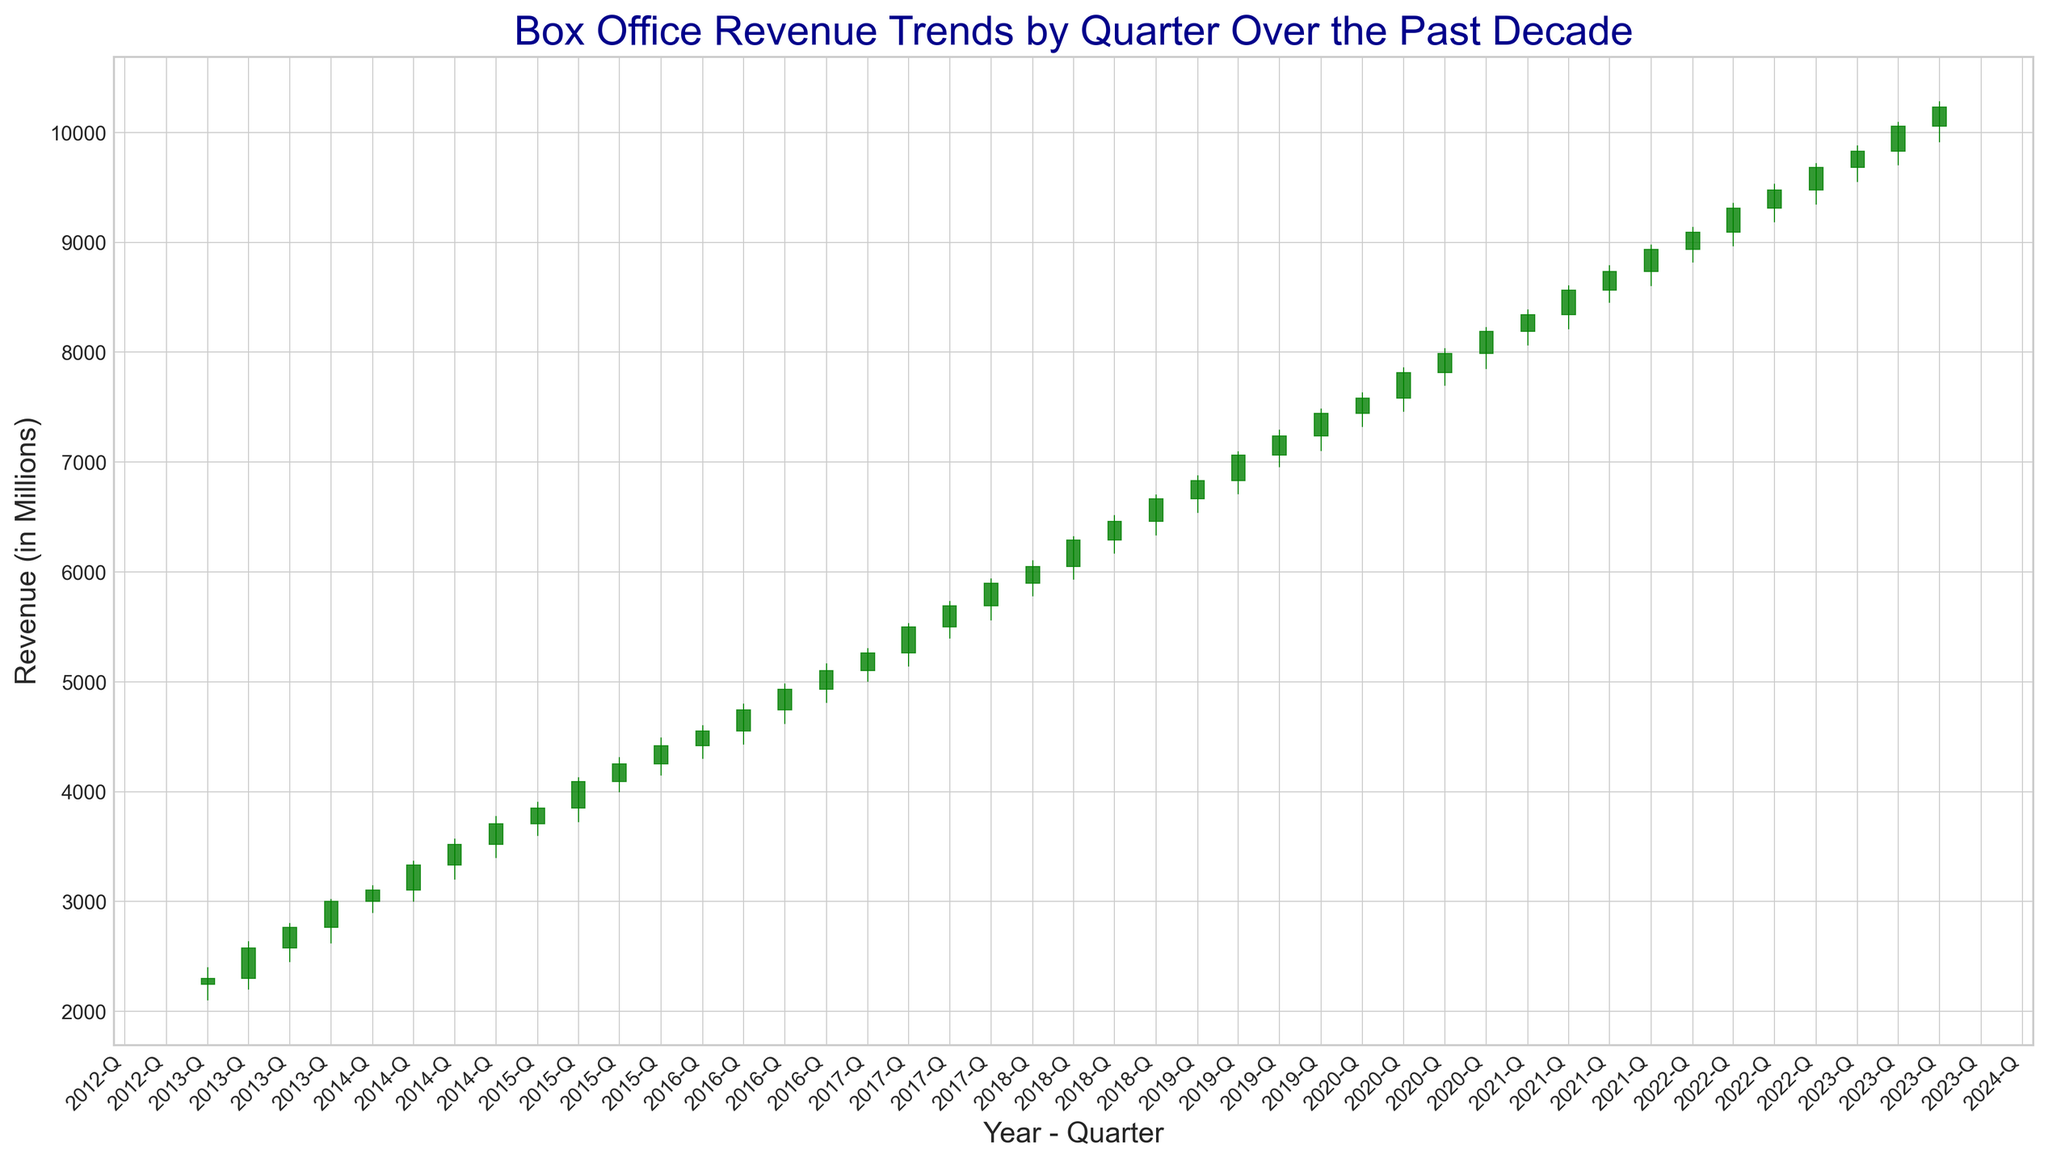Which quarter experienced the highest box office revenue over the past decade? To find the highest box office revenue, look at the "Close" values and identify the tallest green candlestick, as green indicates a positive change. The highest "Close" value appears in 2023 Q3 with a revenue of 10,230.7 million.
Answer: 2023 Q3 Did box office revenues generally increase or decrease during the period of 2013 to 2023? To determine the general trend, observe the overall movement of the "Close" values from 2013 to 2023. Starting around 2,301.5 in Q1 of 2013 and ending at 10,230.7 in Q3 of 2023 indicates a general increase in revenues.
Answer: Increase What was the quarterly revenue change between Q4 2021 and Q1 2022? Subtract the "Close" value of Q4 2021 from Q1 2022. The value for Q4 2021 is 8,936.7, and the Q1 2022 value is 9,090.6. The change is 9,090.6 - 8,936.7 = 153.9 million.
Answer: 153.9 million Which quarters had the lowest and highest opening revenues, and what were those values? Identify the quarters with the smallest and largest "Open" values by looking at the top of the red or green portion of the candlestick. The lowest is in Q1 2013 with 2,245.3 million, and the highest is in Q2 2023 with 9,830.5 million.
Answer: Q1 2013: 2,245.3 million, Q2 2023: 9,830.5 million How many quarters showed a decrease in revenue? Count the number of red candlesticks, as they represent quarters where the "Close" value is less than the "Open" value. There are 4 red candlesticks in total.
Answer: 4 Compare the box office revenue at the end of 2015 to the end of 2020. Which year had higher revenue and by how much? Look at the "Close" values at Q4 2015 and Q4 2020. The values are 4,420.1 and 8,189.7, respectively. 8,189.7 - 4,420.1 = 3,769.6 million. 2020 had higher revenues by 3,769.6 million.
Answer: 2020 by 3,769.6 million What was the average closing revenue for the year 2018? Sum the "Close" values for each quarter in 2018 and divide by the number of quarters (4). (6,050.7 + 6,289.5 + 6,460.8 + 6,664.8) / 4 = 6,366.45 million.
Answer: 6,366.45 million Was there a consistent uptrend in box office revenue every year? Check each year's "Close" values from Q1 to Q4. Note any years where the "Close" values decrease in at least one quarter relative to the previous quarter. Such years exist causing the absence of a consistent uptrend.
Answer: No 